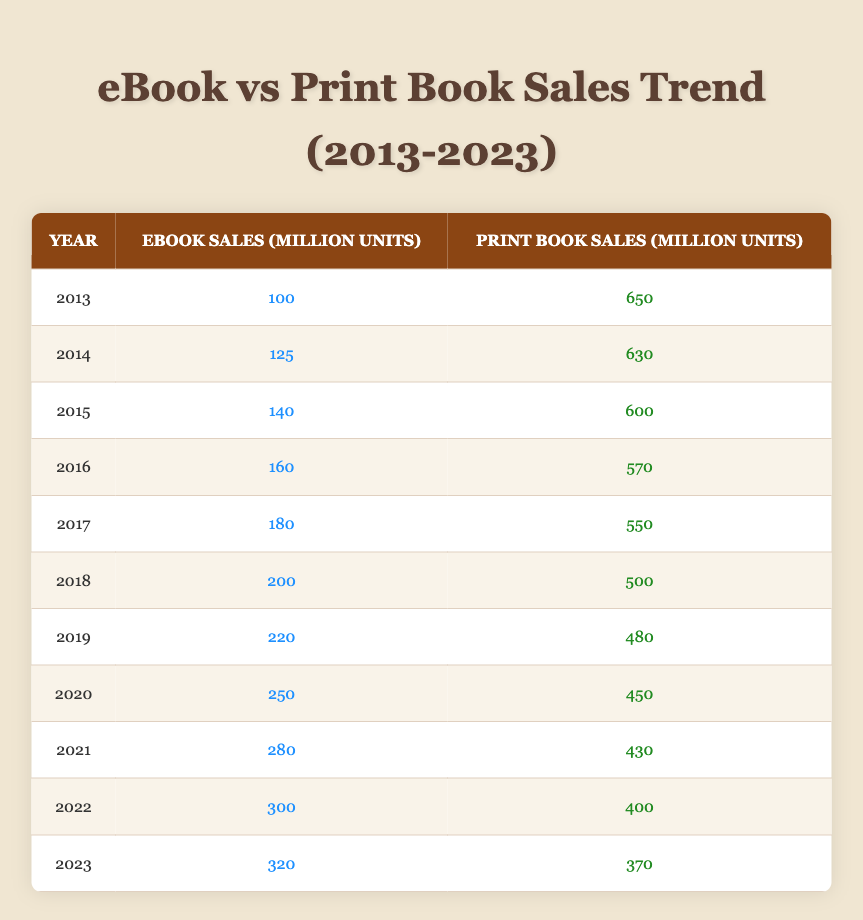What were eBook sales in 2015? Referring to the table, the eBook sales for the year 2015 are listed as 140 million units.
Answer: 140 million units How many print books were sold in 2020? Looking at the table, the print book sales for the year 2020 are indicated as 450 million units.
Answer: 450 million units Which year had the highest eBook sales and what was that number? By examining the table, we see that 2023 had the highest eBook sales with 320 million units.
Answer: 2023; 320 million units What is the difference in eBook sales between 2013 and 2022? In 2013, eBook sales were 100 million units and in 2022 they rose to 300 million units. The difference is calculated as 300 - 100 = 200 million units.
Answer: 200 million units Did eBook sales increase every year from 2013 to 2023? Yes, by checking the sales data in each year from 2013 to 2023, it is evident that sales consistently increased each year.
Answer: Yes What were the total eBook sales from 2013 to 2019? The eBook sales for each year from 2013 to 2019 are 100, 125, 140, 160, 180, 200, and 220 million units respectively. Summing these values gives a total of 1,125 million units for this period.
Answer: 1,125 million units Was there any year in the table when print book sales were higher than eBook sales? Yes, each year from 2013 to 2022 had print book sales that exceeded eBook sales. However, by 2023, eBook sales surpassed print sales.
Answer: Yes What was the average print book sales from 2013 to 2021? The print book sales were 650, 630, 600, 570, 550, 500, 480, 450, and 430 million units for the years 2013 to 2021. Adding these values gives 4,610 million units. Dividing by the number of years (9) results in an average of approximately 512.22 million units.
Answer: 512.22 million units In which year did the print book sales drop below 500 million units for the first time? By checking the table, print book sales first dropped below 500 million units in 2018, when they reached 500 million units, and further declined in subsequent years.
Answer: 2018 